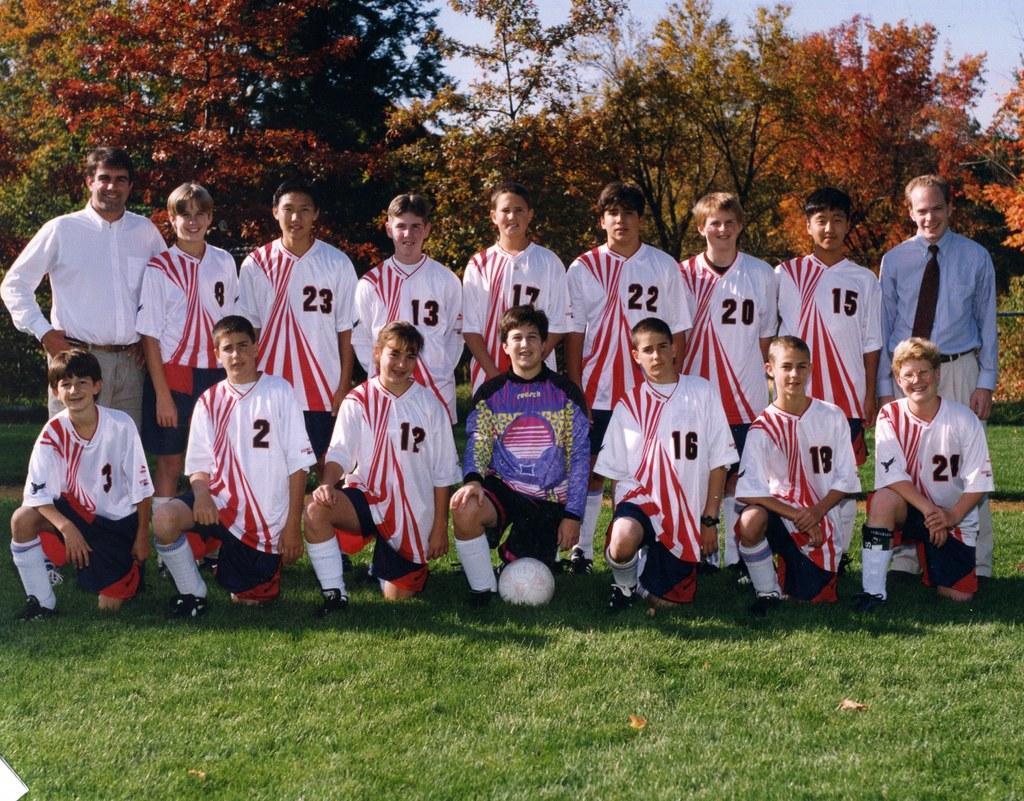How would you summarize this image in a sentence or two? In this picture there are group of people in the center of the image on the grassland and there is a ball on the grassland, there are trees in the background area of the image, it seems to be there is a boundary in the background area of the image. 